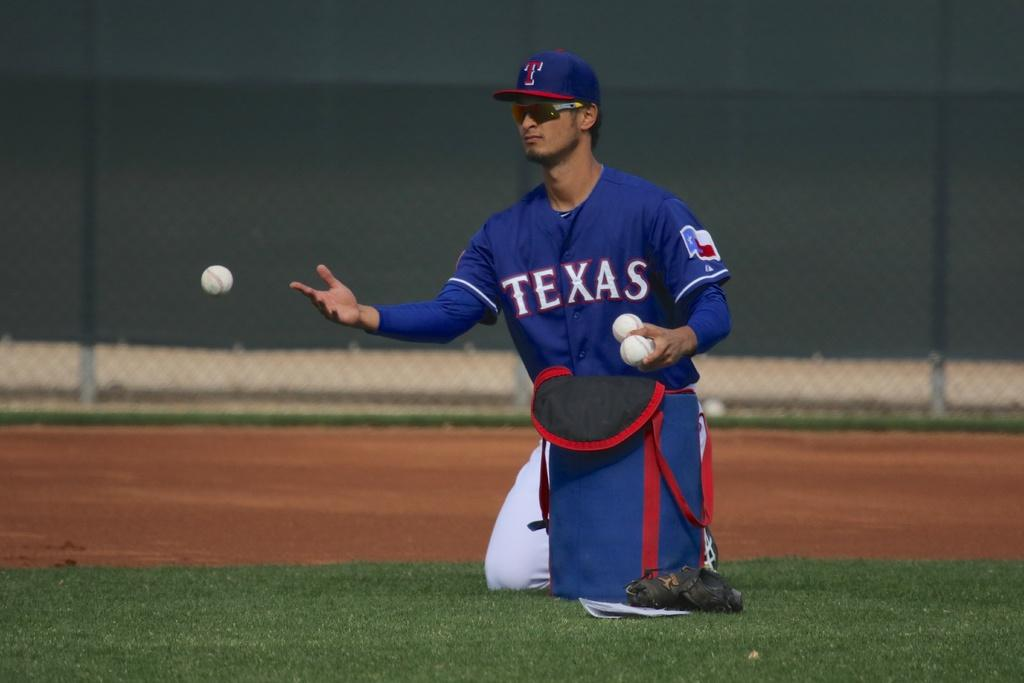<image>
Offer a succinct explanation of the picture presented. A man in a Texas baseball uniform is taking ball out of a blue bag on the field. 